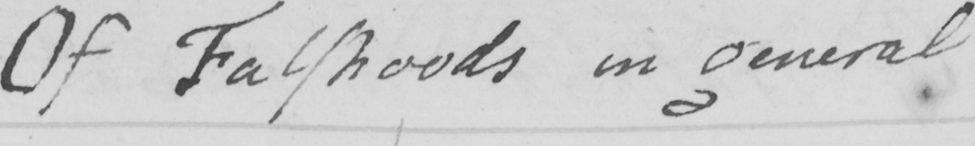What text is written in this handwritten line? Of Falshoods in general 